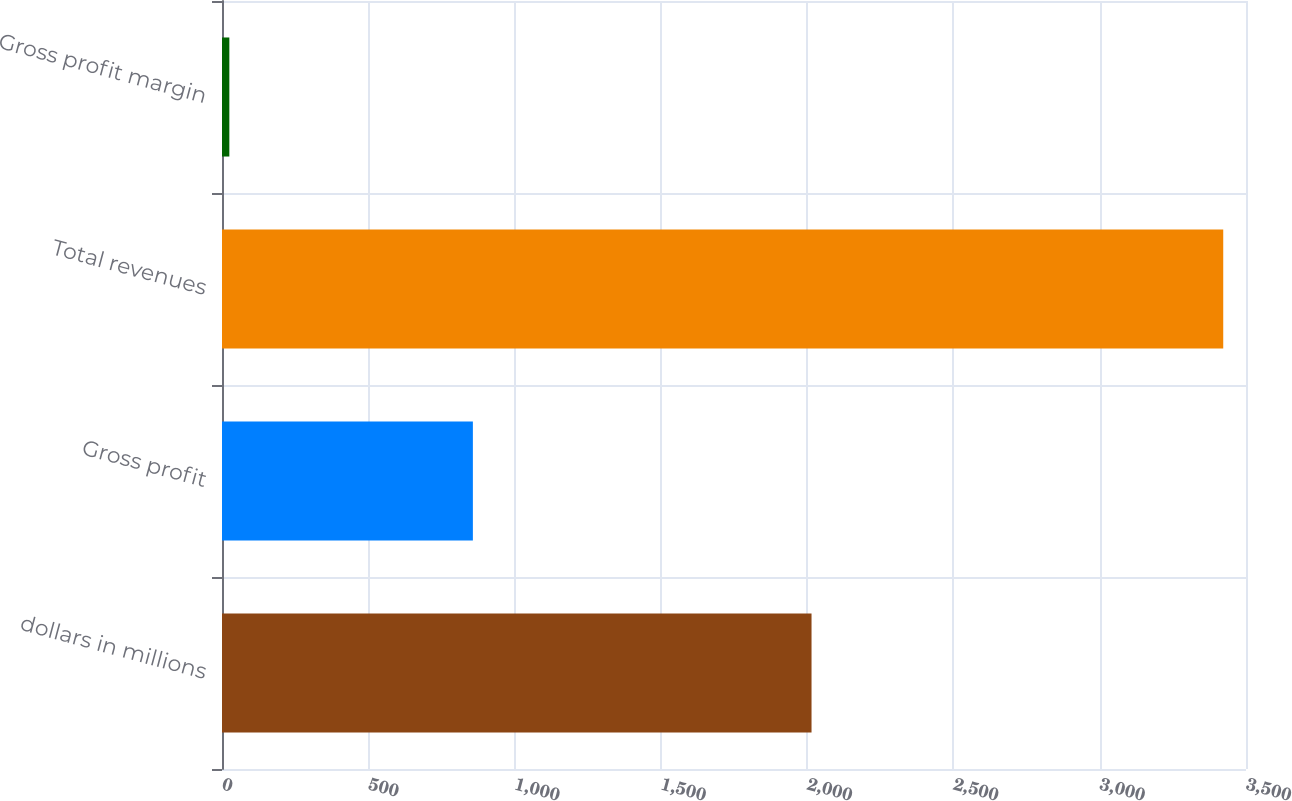Convert chart to OTSL. <chart><loc_0><loc_0><loc_500><loc_500><bar_chart><fcel>dollars in millions<fcel>Gross profit<fcel>Total revenues<fcel>Gross profit margin<nl><fcel>2015<fcel>857.5<fcel>3422.2<fcel>25.1<nl></chart> 